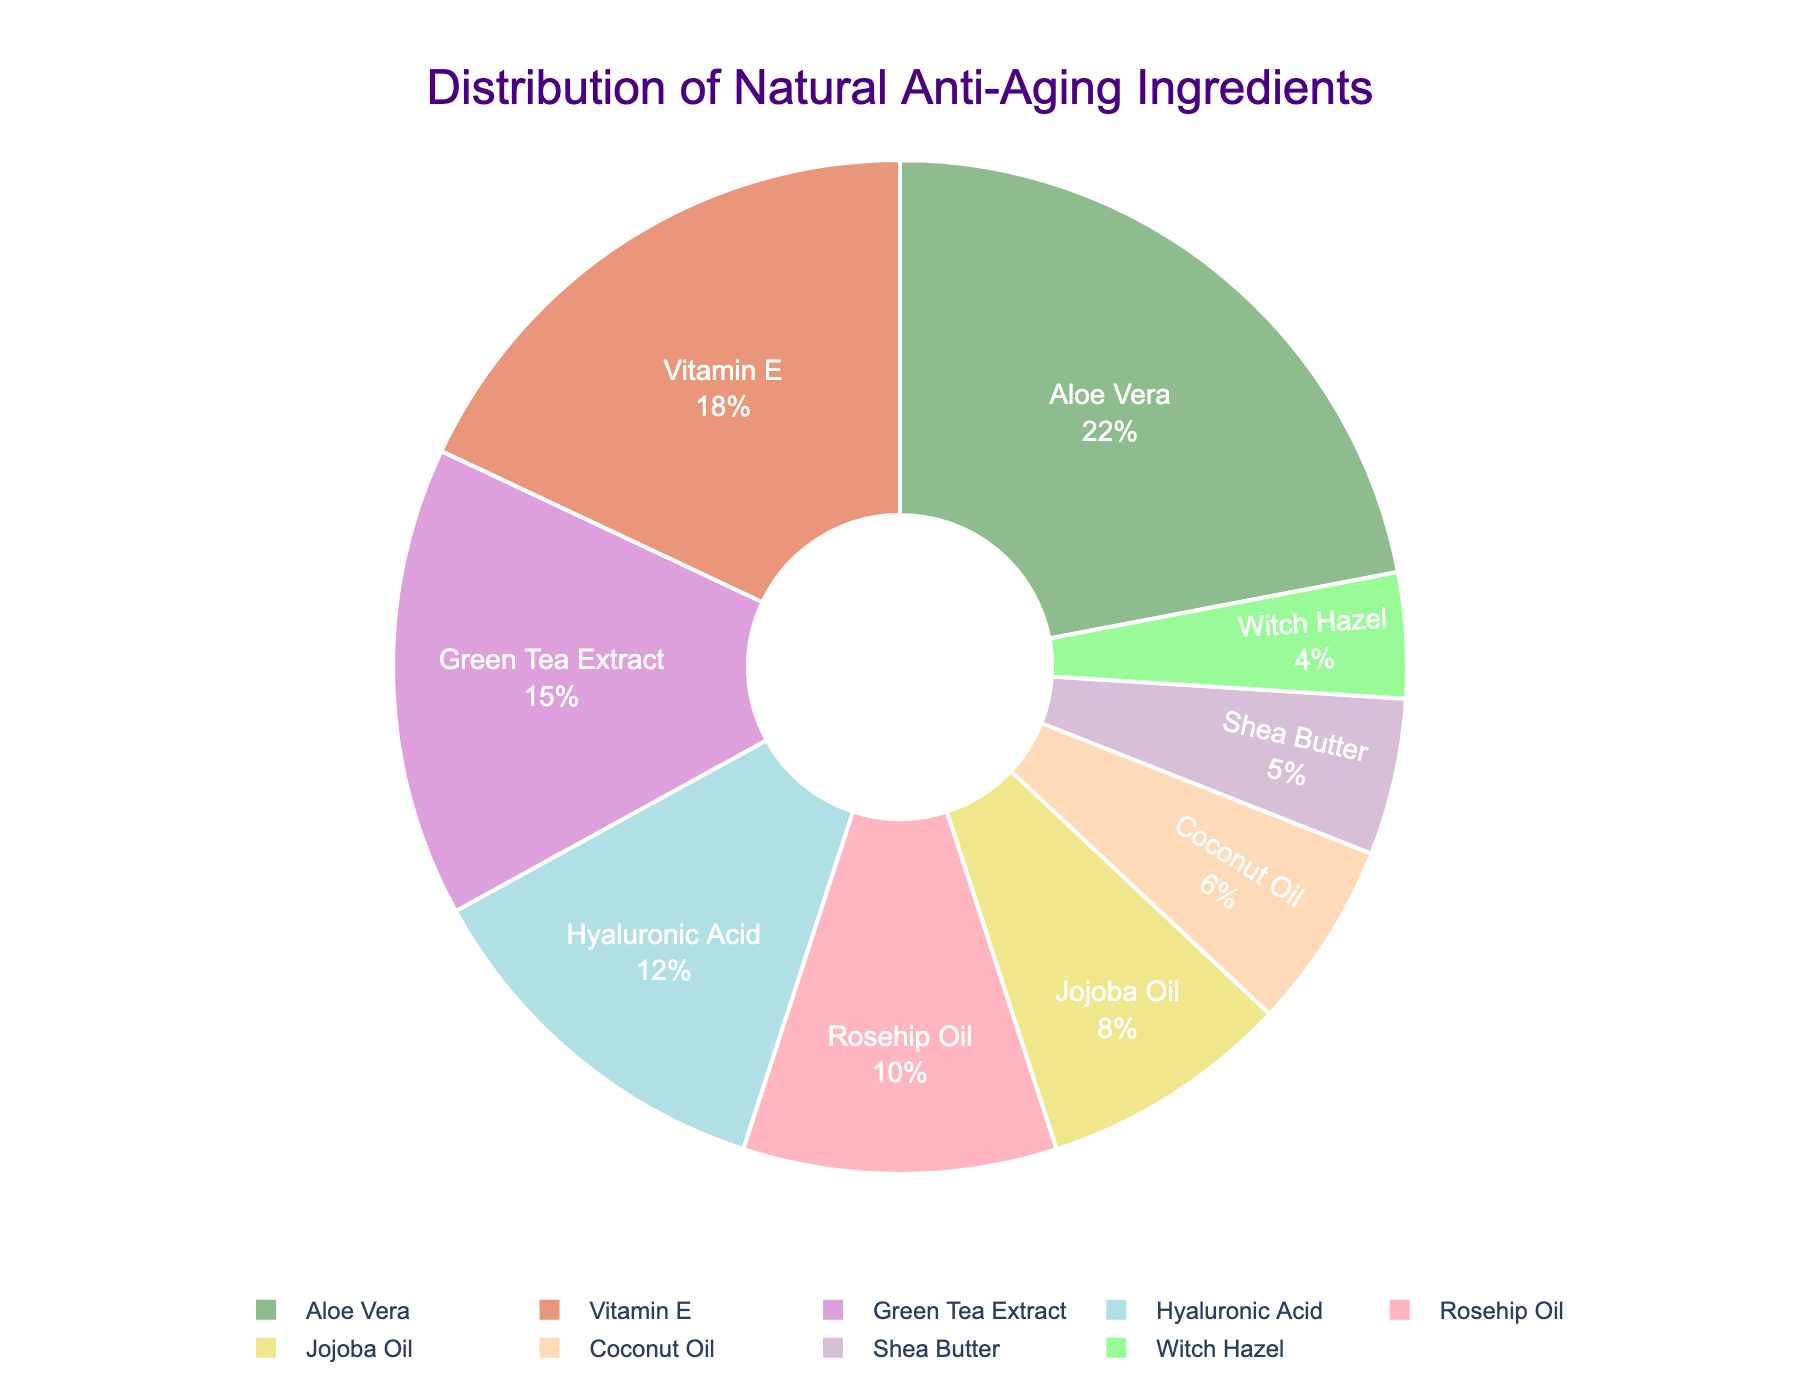What percentage of the pie chart does Aloe Vera represent? Look at the section labeled "Aloe Vera" on the chart. The percentage shown for Aloe Vera is 22%.
Answer: 22% Which ingredient has the highest percentage in the distribution? Identify the ingredient section with the largest slice in the pie chart. Aloe Vera has the highest percentage with 22%.
Answer: Aloe Vera How much greater is the percentage of Aloe Vera compared to Shea Butter? Find the percentages for both Aloe Vera (22%) and Shea Butter (5%). Subtract Shea Butter's percentage from Aloe Vera's percentage: 22% - 5% = 17%.
Answer: 17% What is the combined percentage of Hyaluronic Acid and Rosehip Oil? Look at the sections for Hyaluronic Acid (12%) and Rosehip Oil (10%). Add these two percentages together: 12% + 10% = 22%.
Answer: 22% Is the percentage of Vitamin E greater than Jojoba Oil? Compare the percentages for Vitamin E (18%) and Jojoba Oil (8%). Since 18% is greater than 8%, the answer is yes.
Answer: Yes Among Green Tea Extract, Coconut Oil, and Witch Hazel, which ingredient has the smallest percentage? Compare the percentages of Green Tea Extract (15%), Coconut Oil (6%), and Witch Hazel (4%). Witch Hazel has the smallest percentage.
Answer: Witch Hazel What are the ingredients with percentages above 15%? Identify the ingredients with percentages higher than 15%. Aloe Vera (22%) and Vitamin E (18%) meet this criterion.
Answer: Aloe Vera, Vitamin E What is the total percentage of ingredients labeled with "Oil"? Find the slices labeled with "Oil" and sum their percentages: Rosehip Oil (10%), Jojoba Oil (8%), and Coconut Oil (6%). Add these numbers together: 10% + 8% + 6% = 24%.
Answer: 24% Are there more ingredients with percentages above 10% or below 10%? Count the number of ingredients above 10% (Aloe Vera, Vitamin E, Green Tea Extract, Hyaluronic Acid, Rosehip Oil = 5) and below 10% (Jojoba Oil, Coconut Oil, Shea Butter, Witch Hazel = 4). There are more ingredients above 10%.
Answer: Above 10% What is the difference between the largest and smallest percentages? The largest percentage is Aloe Vera (22%) and the smallest is Witch Hazel (4%). Subtract the smallest from the largest: 22% - 4% = 18%.
Answer: 18% 